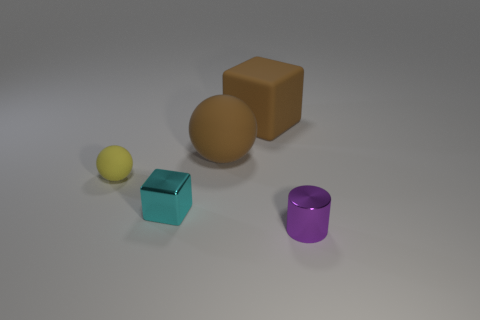Add 3 cylinders. How many objects exist? 8 Subtract all balls. How many objects are left? 3 Add 5 large purple cylinders. How many large purple cylinders exist? 5 Subtract 0 purple balls. How many objects are left? 5 Subtract all tiny blue blocks. Subtract all brown rubber cubes. How many objects are left? 4 Add 5 big objects. How many big objects are left? 7 